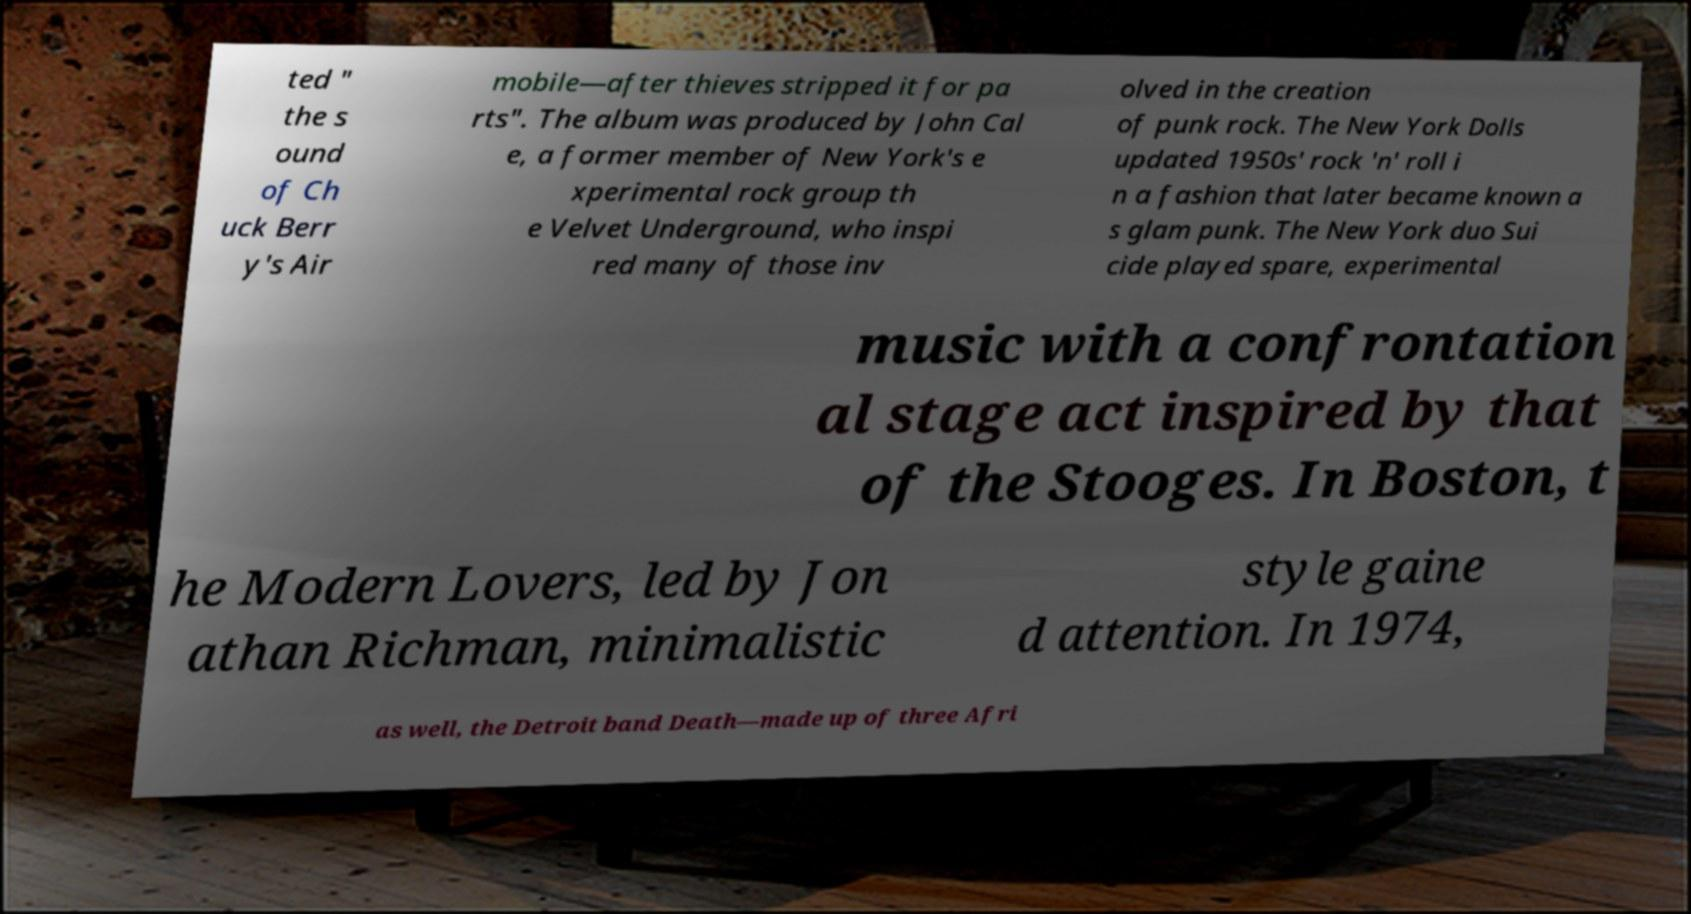Could you extract and type out the text from this image? ted " the s ound of Ch uck Berr y's Air mobile—after thieves stripped it for pa rts". The album was produced by John Cal e, a former member of New York's e xperimental rock group th e Velvet Underground, who inspi red many of those inv olved in the creation of punk rock. The New York Dolls updated 1950s' rock 'n' roll i n a fashion that later became known a s glam punk. The New York duo Sui cide played spare, experimental music with a confrontation al stage act inspired by that of the Stooges. In Boston, t he Modern Lovers, led by Jon athan Richman, minimalistic style gaine d attention. In 1974, as well, the Detroit band Death—made up of three Afri 